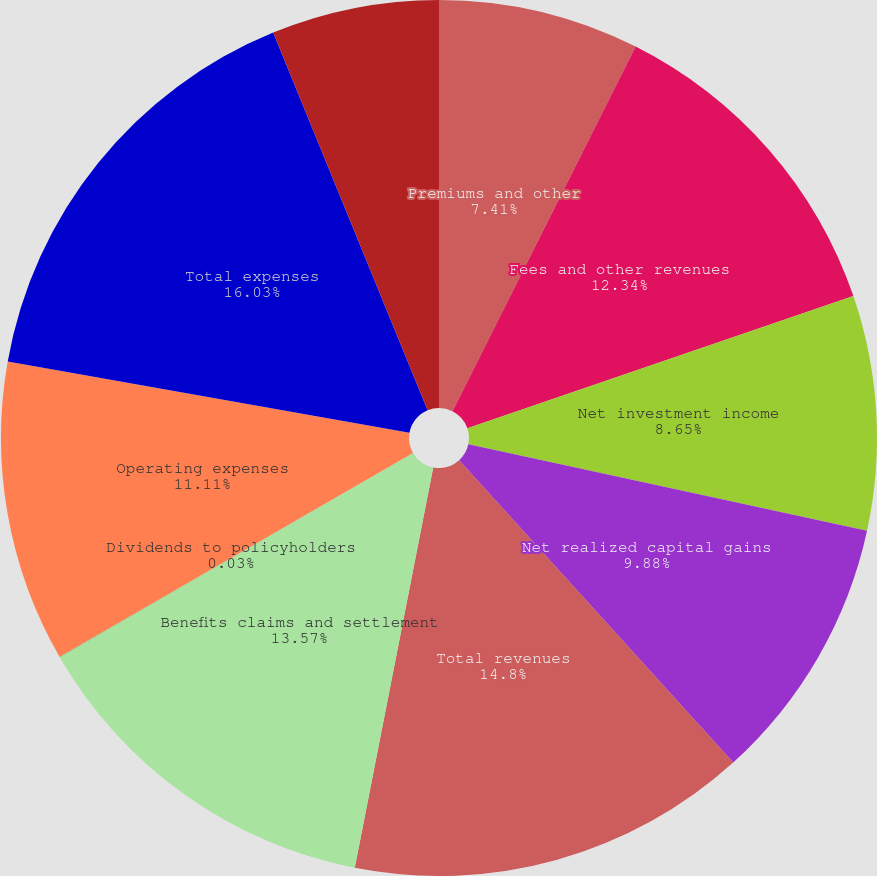Convert chart to OTSL. <chart><loc_0><loc_0><loc_500><loc_500><pie_chart><fcel>Premiums and other<fcel>Fees and other revenues<fcel>Net investment income<fcel>Net realized capital gains<fcel>Total revenues<fcel>Benefits claims and settlement<fcel>Dividends to policyholders<fcel>Operating expenses<fcel>Total expenses<fcel>Income from continuing<nl><fcel>7.41%<fcel>12.34%<fcel>8.65%<fcel>9.88%<fcel>14.8%<fcel>13.57%<fcel>0.03%<fcel>11.11%<fcel>16.03%<fcel>6.18%<nl></chart> 